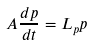<formula> <loc_0><loc_0><loc_500><loc_500>A \frac { d p } { d t } = L _ { p } p</formula> 